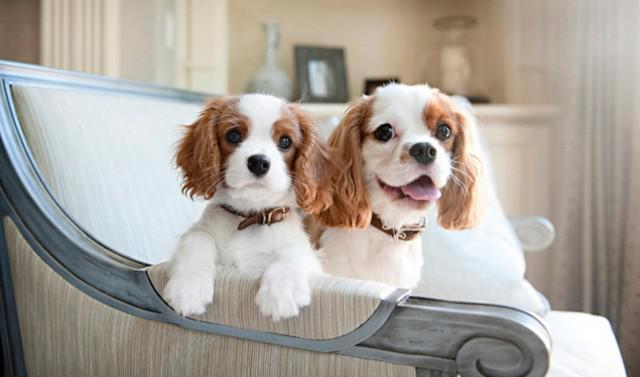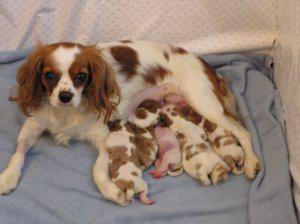The first image is the image on the left, the second image is the image on the right. Examine the images to the left and right. Is the description "The right image shows an adult, brown and white colored cocker spaniel mom with multiple puppies nursing" accurate? Answer yes or no. Yes. 